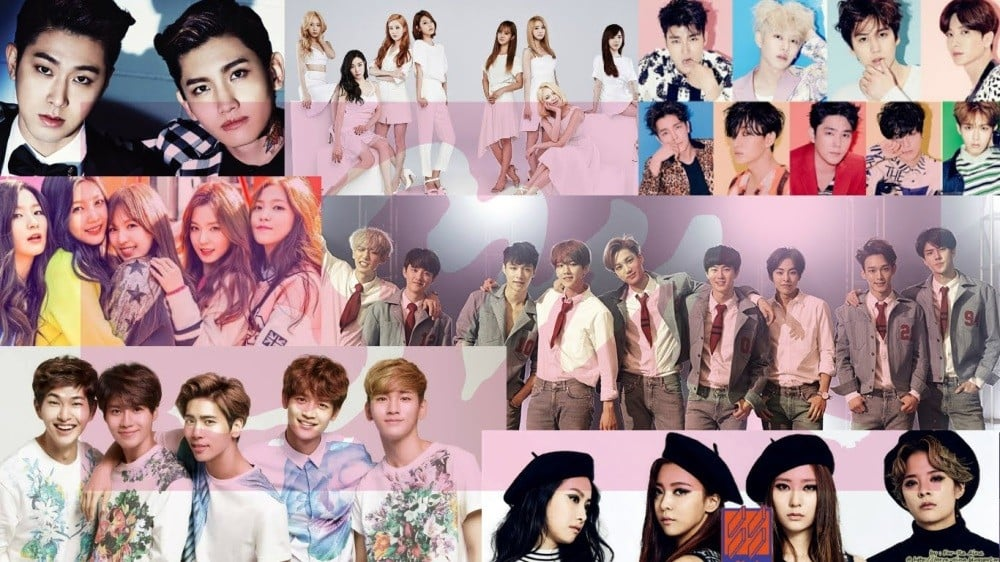How does the background and staging in the photograph contribute to the overall image and presentation of these groups? The background and staging in the photograph serve to enhance the overall presentation and thematic elements associated with each K-pop group. By utilizing carefully curated backdrops, lighting, and props, the photograph is able to convey specific concepts and moods that align with the group's branding and the narrative they wish to project. The background provides context and depth, either complementing the group's attire and image or contrasting it to add visual interest. Effective staging can highlight individual members while maintaining the group's collective identity, ensuring each member's unique characteristics are showcased within the unified theme. This meticulous attention to detail in background and staging is essential for creating a compelling visual narrative that captures the viewer's attention and conveys the desired artistic vision. 